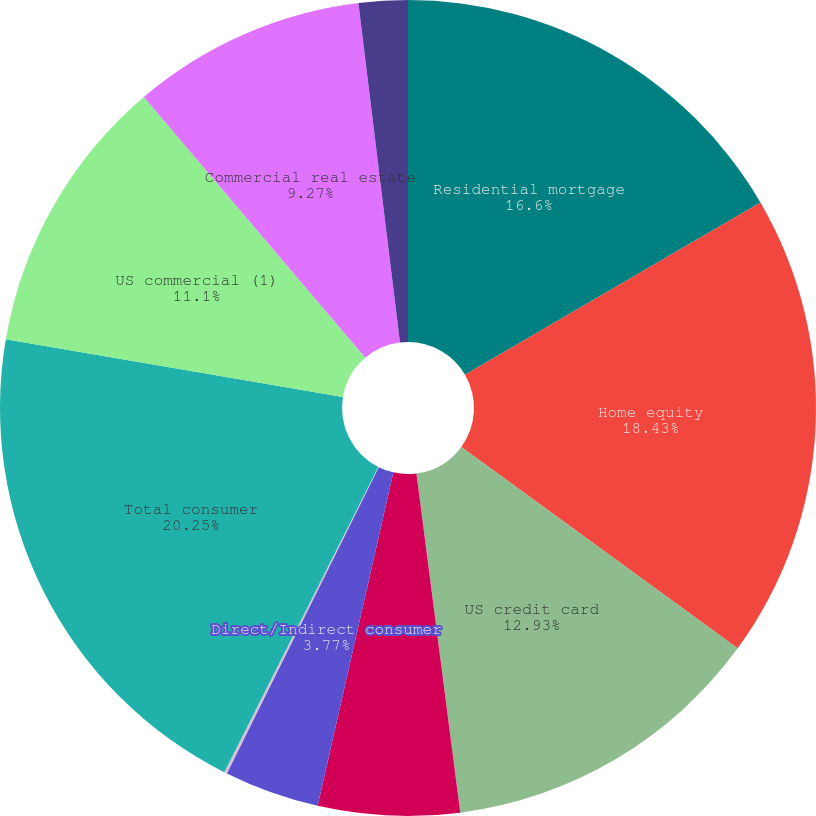Convert chart. <chart><loc_0><loc_0><loc_500><loc_500><pie_chart><fcel>Residential mortgage<fcel>Home equity<fcel>US credit card<fcel>Non-US credit card<fcel>Direct/Indirect consumer<fcel>Other consumer<fcel>Total consumer<fcel>US commercial (1)<fcel>Commercial real estate<fcel>Commercial lease financing<nl><fcel>16.6%<fcel>18.43%<fcel>12.93%<fcel>5.6%<fcel>3.77%<fcel>0.11%<fcel>20.26%<fcel>11.1%<fcel>9.27%<fcel>1.94%<nl></chart> 